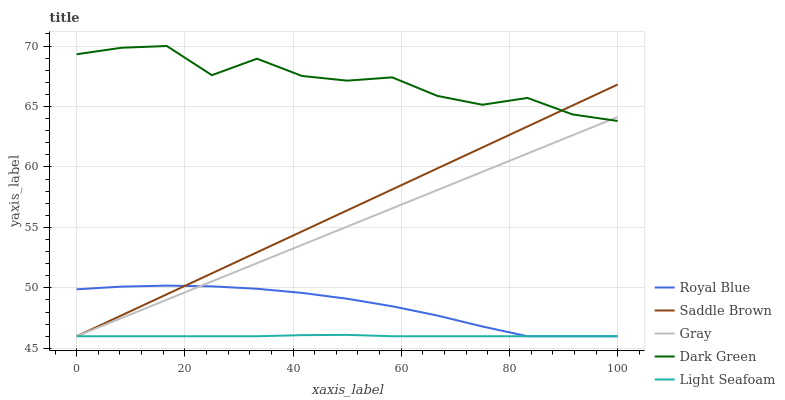Does Light Seafoam have the minimum area under the curve?
Answer yes or no. Yes. Does Dark Green have the maximum area under the curve?
Answer yes or no. Yes. Does Saddle Brown have the minimum area under the curve?
Answer yes or no. No. Does Saddle Brown have the maximum area under the curve?
Answer yes or no. No. Is Saddle Brown the smoothest?
Answer yes or no. Yes. Is Dark Green the roughest?
Answer yes or no. Yes. Is Dark Green the smoothest?
Answer yes or no. No. Is Saddle Brown the roughest?
Answer yes or no. No. Does Royal Blue have the lowest value?
Answer yes or no. Yes. Does Dark Green have the lowest value?
Answer yes or no. No. Does Dark Green have the highest value?
Answer yes or no. Yes. Does Saddle Brown have the highest value?
Answer yes or no. No. Is Light Seafoam less than Dark Green?
Answer yes or no. Yes. Is Dark Green greater than Light Seafoam?
Answer yes or no. Yes. Does Saddle Brown intersect Light Seafoam?
Answer yes or no. Yes. Is Saddle Brown less than Light Seafoam?
Answer yes or no. No. Is Saddle Brown greater than Light Seafoam?
Answer yes or no. No. Does Light Seafoam intersect Dark Green?
Answer yes or no. No. 